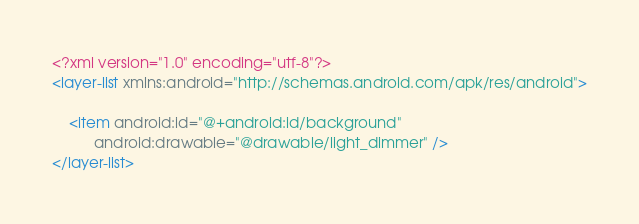Convert code to text. <code><loc_0><loc_0><loc_500><loc_500><_XML_><?xml version="1.0" encoding="utf-8"?>
<layer-list xmlns:android="http://schemas.android.com/apk/res/android">

	<item android:id="@+android:id/background"
	      android:drawable="@drawable/light_dimmer" />
</layer-list></code> 